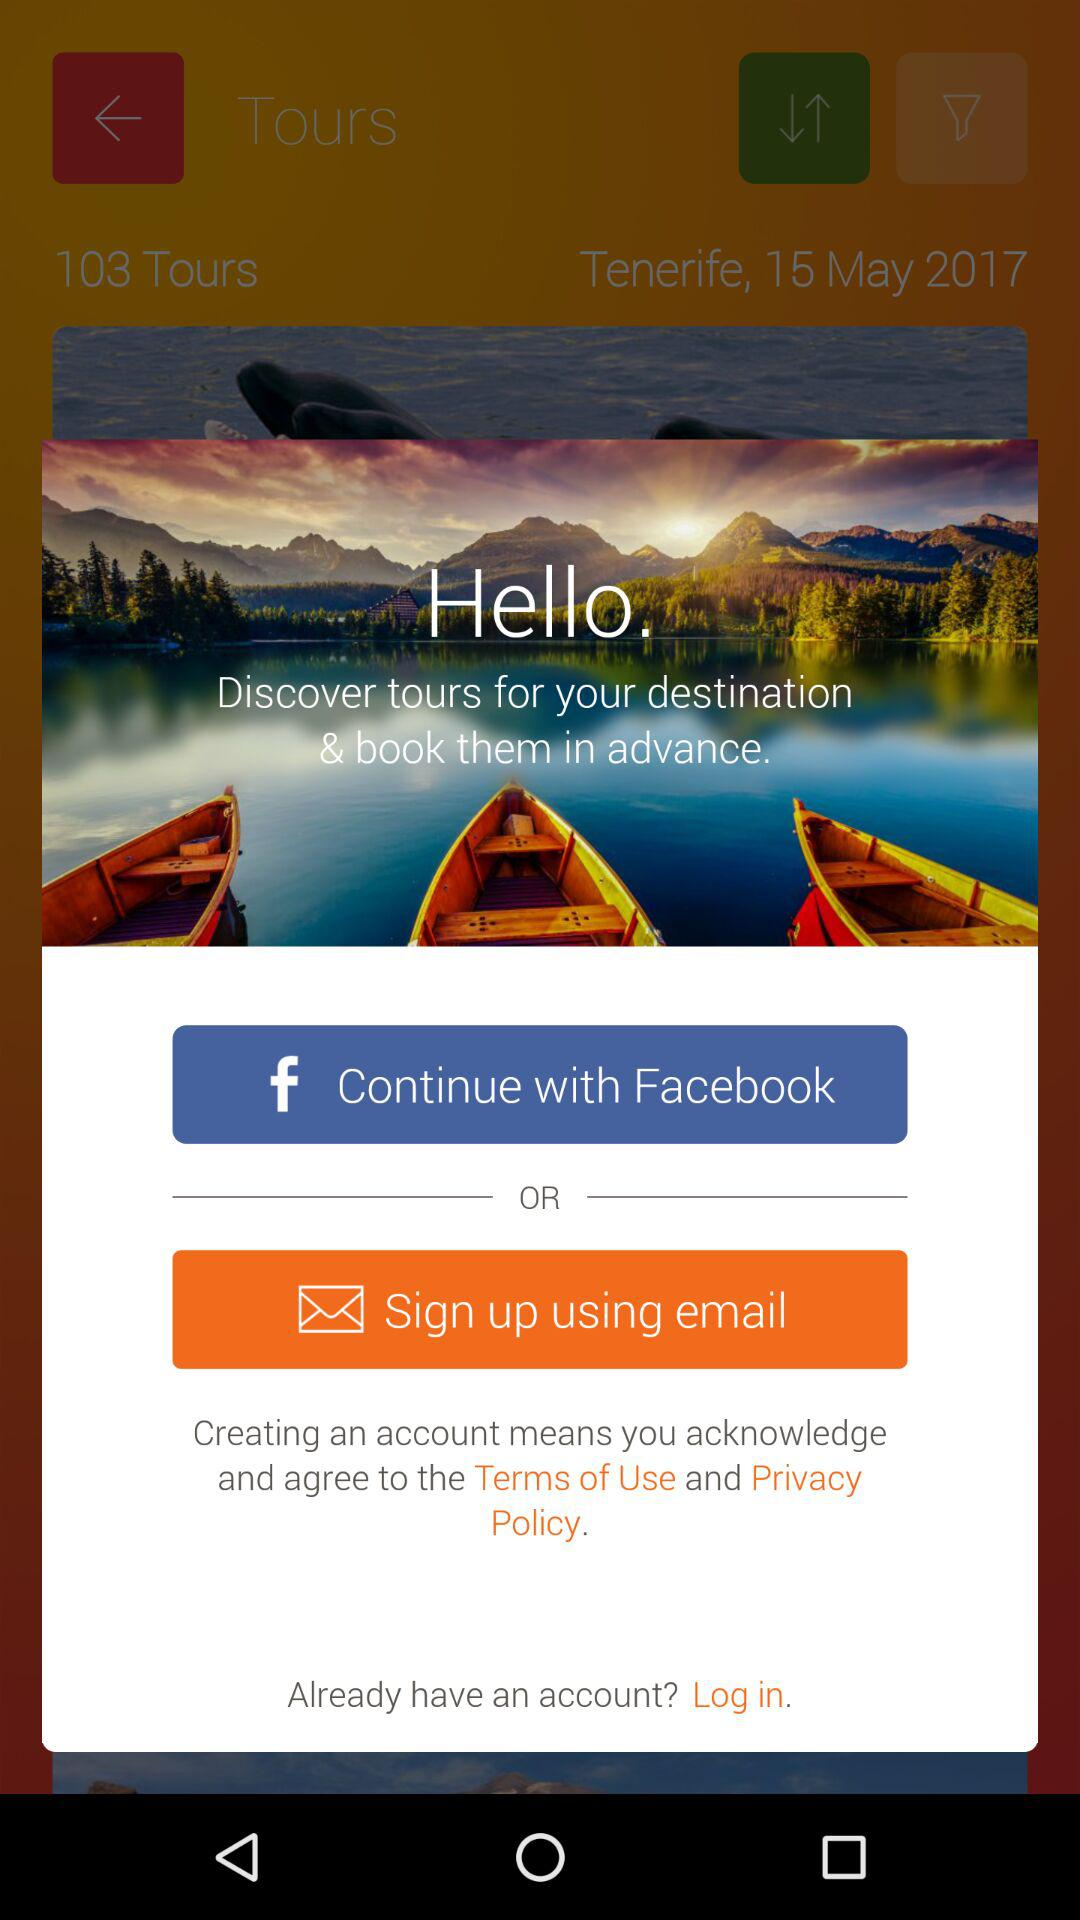What are the different options available for signing up? The different options are "Facebook" and "email". 